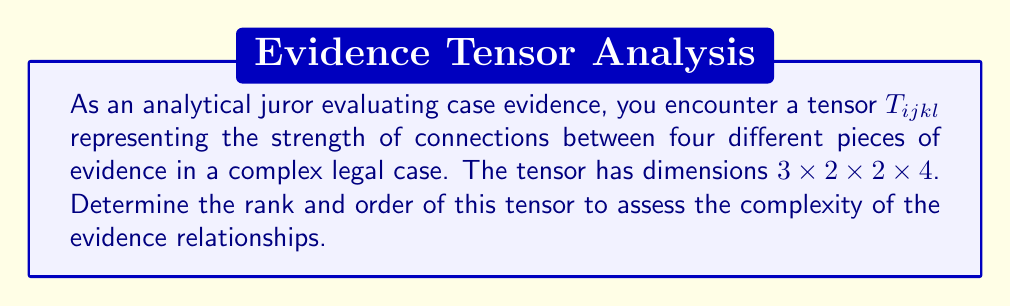Help me with this question. To determine the rank and order of the tensor $T_{ijkl}$, we need to analyze its structure:

1. Rank of a tensor:
   The rank of a tensor is the number of indices it has. In this case, $T_{ijkl}$ has four indices (i, j, k, and l), so:
   Rank = 4

2. Order of a tensor:
   The order of a tensor is the number of dimensions it has. We can determine this by counting the number of dimensions given:
   - i ranges from 1 to 3
   - j ranges from 1 to 2
   - k ranges from 1 to 2
   - l ranges from 1 to 4

   Therefore, the tensor has 4 dimensions, so:
   Order = 4

It's important to note that for tensors, the rank and order are often the same, as is the case here. This is because each index typically corresponds to a dimension in the tensor's structure.

In the context of evaluating case evidence, a rank-4 tensor with order 4 suggests a complex relationship between four different aspects or pieces of evidence, each potentially having multiple components or categories.
Answer: Rank: 4, Order: 4 